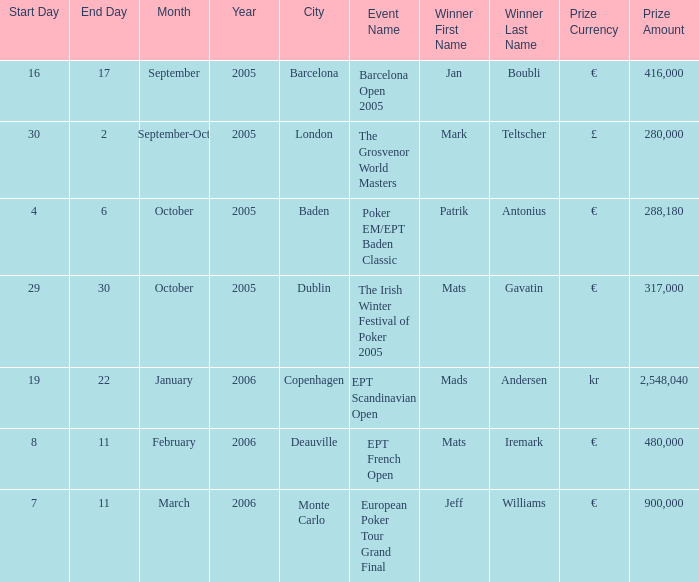When did the event in dublin take place? 29–30 October 2005. 